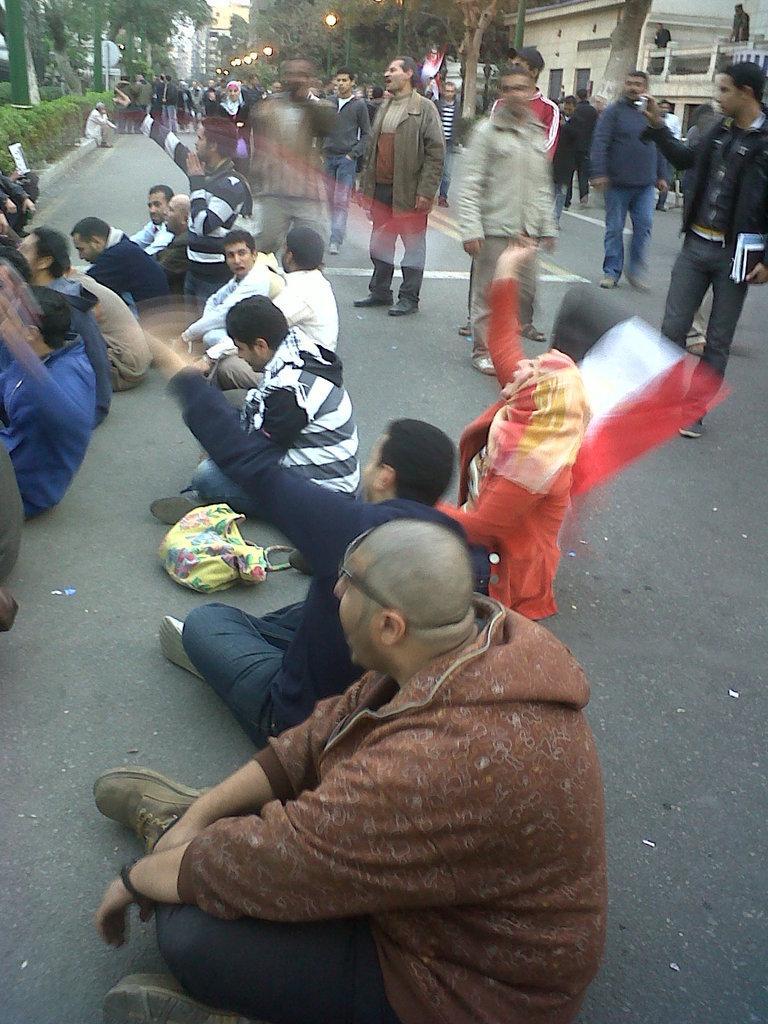How would you summarize this image in a sentence or two? In this image we can see group of persons sitting and some are standing on road, holding some flags in their hands and in the background of image there are some trees, lights and clear sky. 